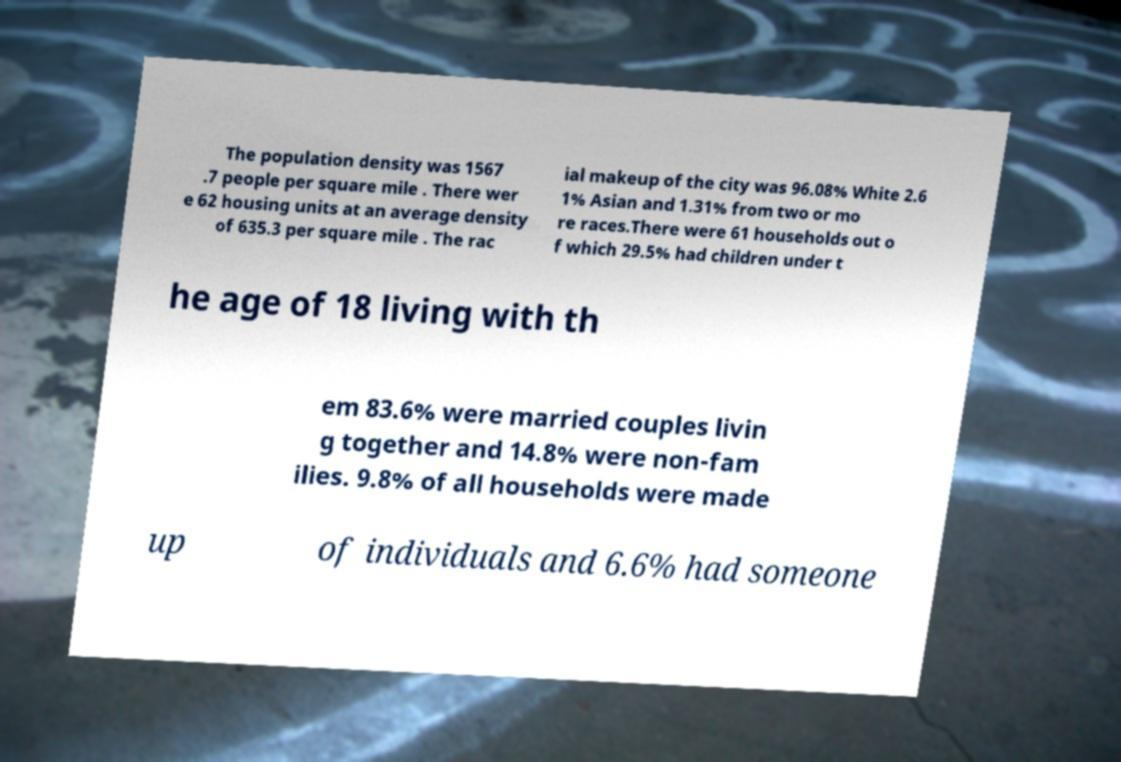Please read and relay the text visible in this image. What does it say? The population density was 1567 .7 people per square mile . There wer e 62 housing units at an average density of 635.3 per square mile . The rac ial makeup of the city was 96.08% White 2.6 1% Asian and 1.31% from two or mo re races.There were 61 households out o f which 29.5% had children under t he age of 18 living with th em 83.6% were married couples livin g together and 14.8% were non-fam ilies. 9.8% of all households were made up of individuals and 6.6% had someone 